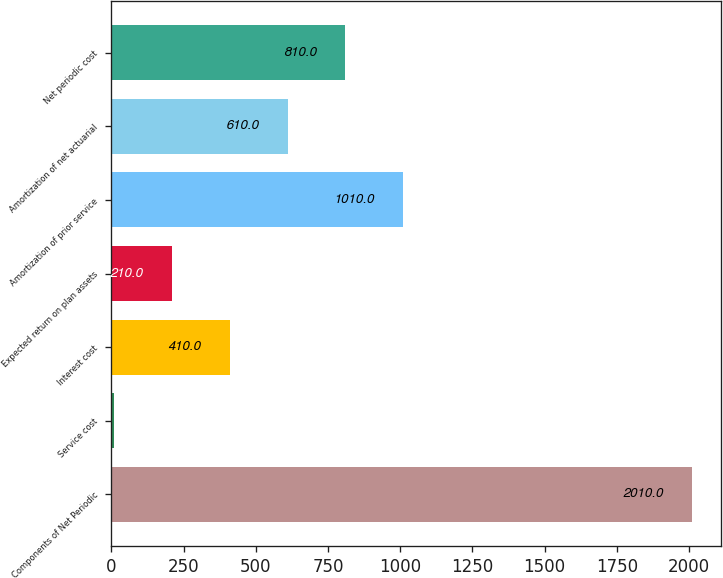Convert chart. <chart><loc_0><loc_0><loc_500><loc_500><bar_chart><fcel>Components of Net Periodic<fcel>Service cost<fcel>Interest cost<fcel>Expected return on plan assets<fcel>Amortization of prior service<fcel>Amortization of net actuarial<fcel>Net periodic cost<nl><fcel>2010<fcel>10<fcel>410<fcel>210<fcel>1010<fcel>610<fcel>810<nl></chart> 